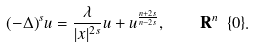Convert formula to latex. <formula><loc_0><loc_0><loc_500><loc_500>( - \Delta ) ^ { s } u = \frac { \lambda } { | x | ^ { 2 s } } u + u ^ { \frac { n + 2 s } { n - 2 s } } , \quad \mathbf R ^ { n } \ \{ 0 \} .</formula> 